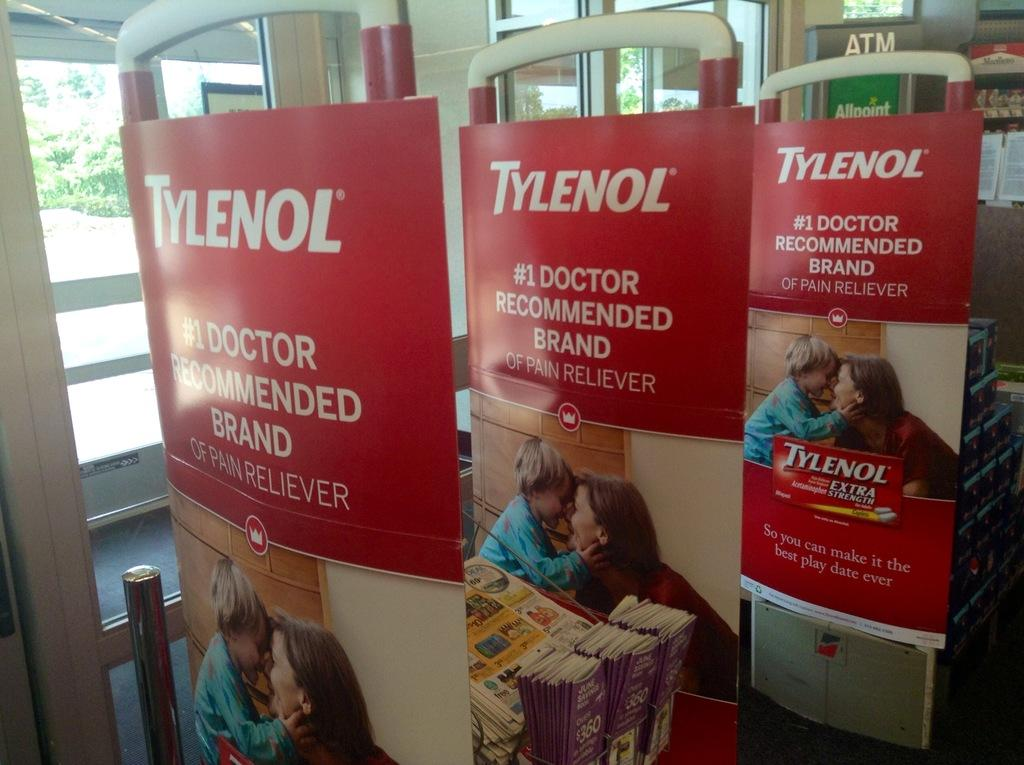<image>
Provide a brief description of the given image. Security scanners with posters of Tylenol, the number one recommended brand by doctors. 